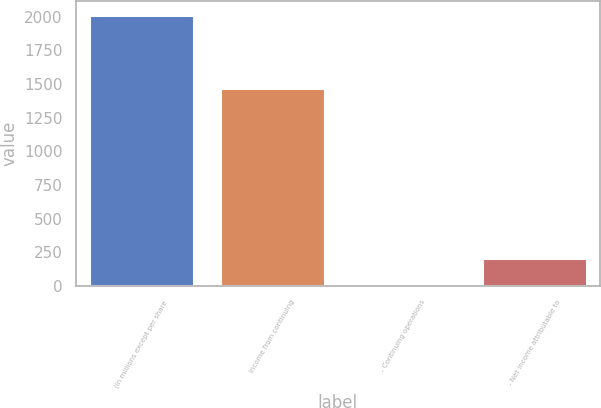<chart> <loc_0><loc_0><loc_500><loc_500><bar_chart><fcel>(In millions except per share<fcel>Income from continuing<fcel>- Continuing operations<fcel>- Net income attributable to<nl><fcel>2014<fcel>1471<fcel>2.65<fcel>203.78<nl></chart> 